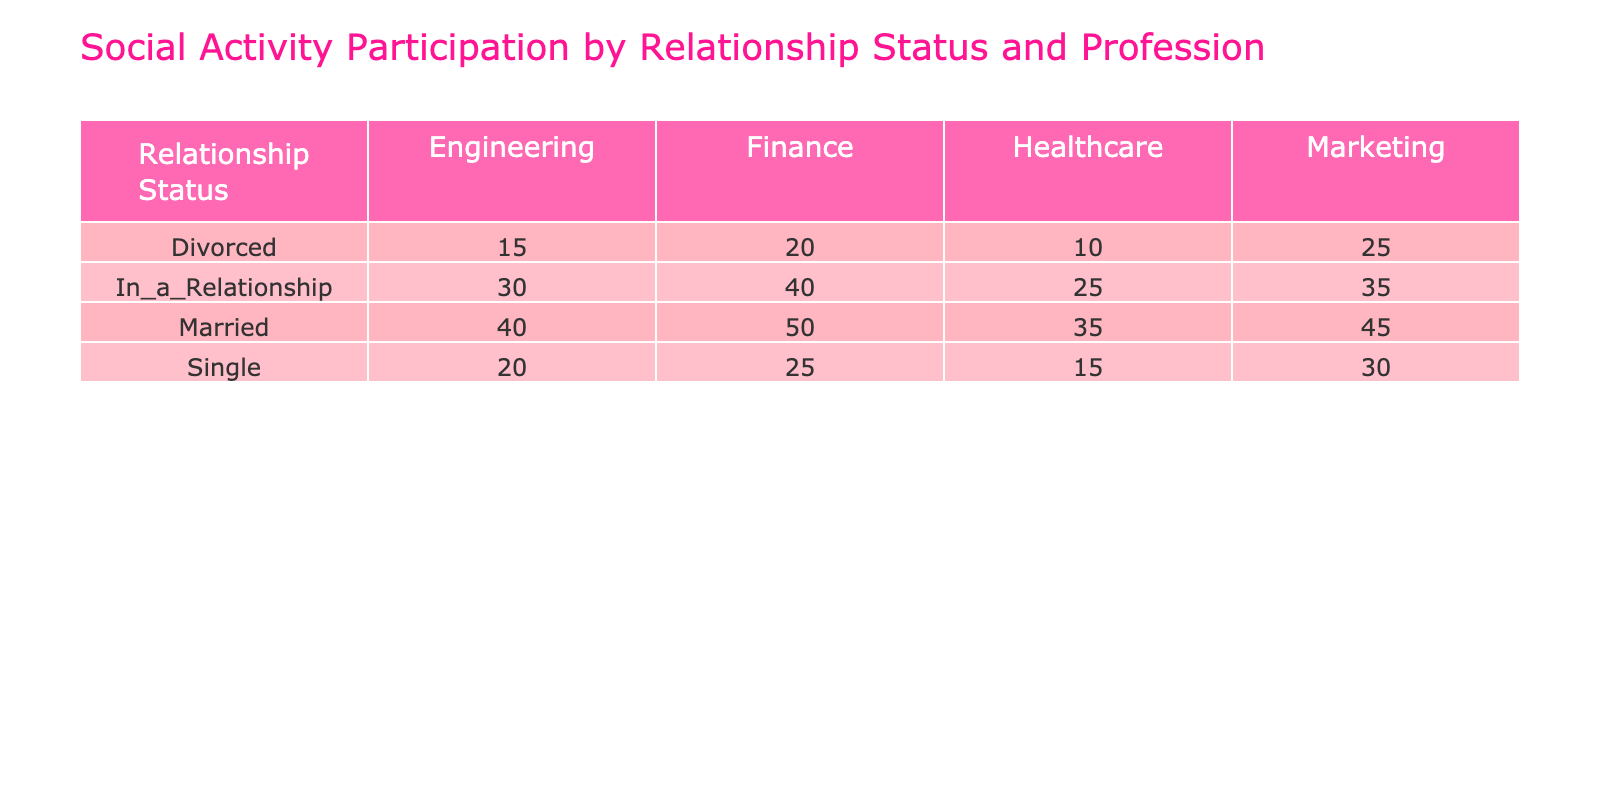What is the social activity participation of married finance professionals? The table shows that the social activity participation of married finance professionals is 50.
Answer: 50 Which profession has the highest social activity participation among those in a relationship? Looking at the values for those in a relationship, finance has the highest participation with a value of 40.
Answer: Finance What is the total social activity participation for divorced individuals across all professions? To find the total, sum the values for divorced individuals: 20 (Finance) + 25 (Marketing) + 15 (Engineering) + 10 (Healthcare) = 70.
Answer: 70 Is the social activity participation of single healthcare professionals greater than that of divorced healthcare professionals? The table shows that single healthcare professionals participate at a value of 15, while divorced healthcare professionals participate at 10. Since 15 > 10, the answer is yes.
Answer: Yes What is the difference in social activity participation between married and single marketing professionals? The participation for married marketing professionals is 45 and for single is 30. The difference is 45 - 30 = 15.
Answer: 15 Which relationship status has the lowest total social activity participation across all professions? To find this, sum the participation values for each relationship status: Single = 100, In a Relationship = 130, Married = 170, Divorced = 70. Divorced has the lowest total of 70.
Answer: Divorced What percentage of social activity participants in finance are married? The total for finance is 25 (Single) + 40 (In a Relationship) + 50 (Married) + 20 (Divorced) = 135. The married total is 50. Therefore, percentage = (50/135) * 100 ≈ 37.04%.
Answer: Approximately 37.04% Do divorced healthcare professionals participate in social activities more than single engineering professionals? The participation for divorced healthcare professionals is 10 and for single engineering professionals is 20. Since 10 < 20, the answer is no.
Answer: No 